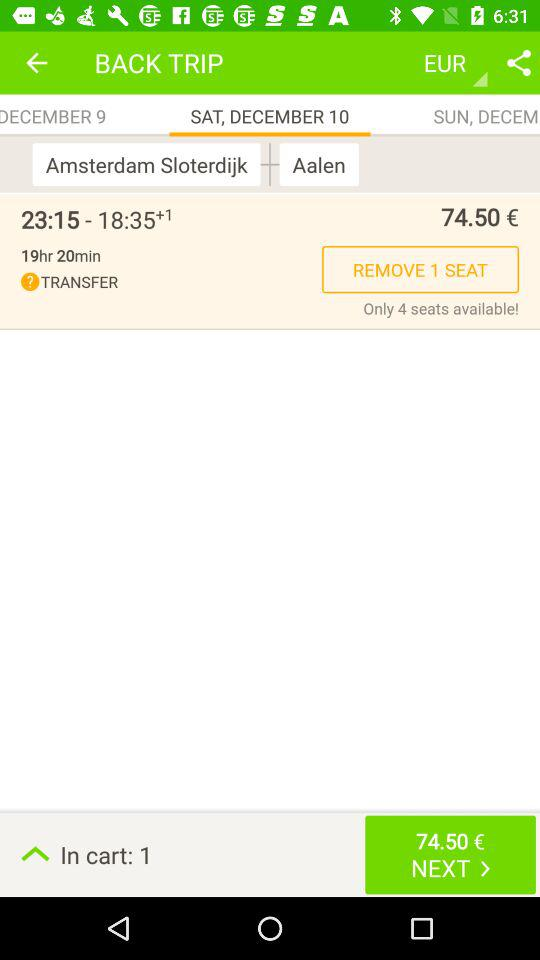How many seats are there in the cart? There is 1 seat in the cart. 